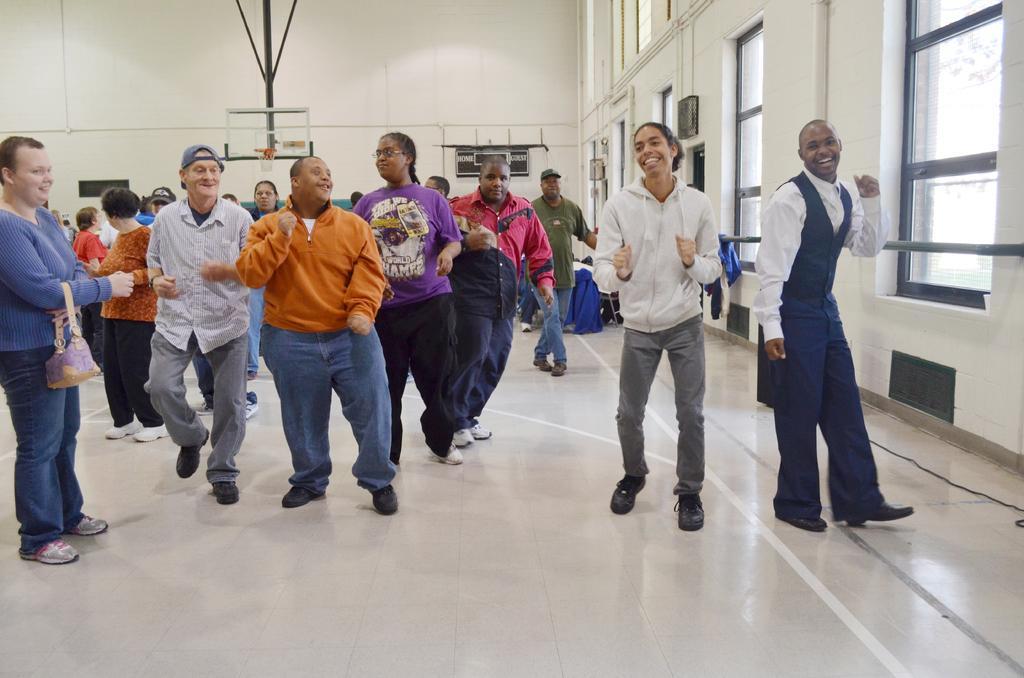Please provide a concise description of this image. In this image I can see number of persons are standing on the floor which is white in color. In the background I can see few windows, the white colored wall, the basket ball goal post and few blue colored objects on the floor. 